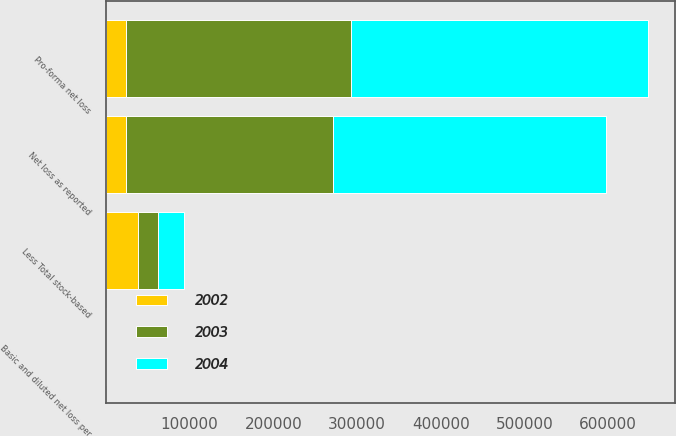Convert chart. <chart><loc_0><loc_0><loc_500><loc_500><stacked_bar_chart><ecel><fcel>Net loss as reported<fcel>Less Total stock-based<fcel>Pro-forma net loss<fcel>Basic and diluted net loss per<nl><fcel>2003<fcel>247587<fcel>23906<fcel>269196<fcel>1.2<nl><fcel>2004<fcel>325321<fcel>31156<fcel>354400<fcel>1.7<nl><fcel>2002<fcel>23906<fcel>38126<fcel>23906<fcel>6.15<nl></chart> 